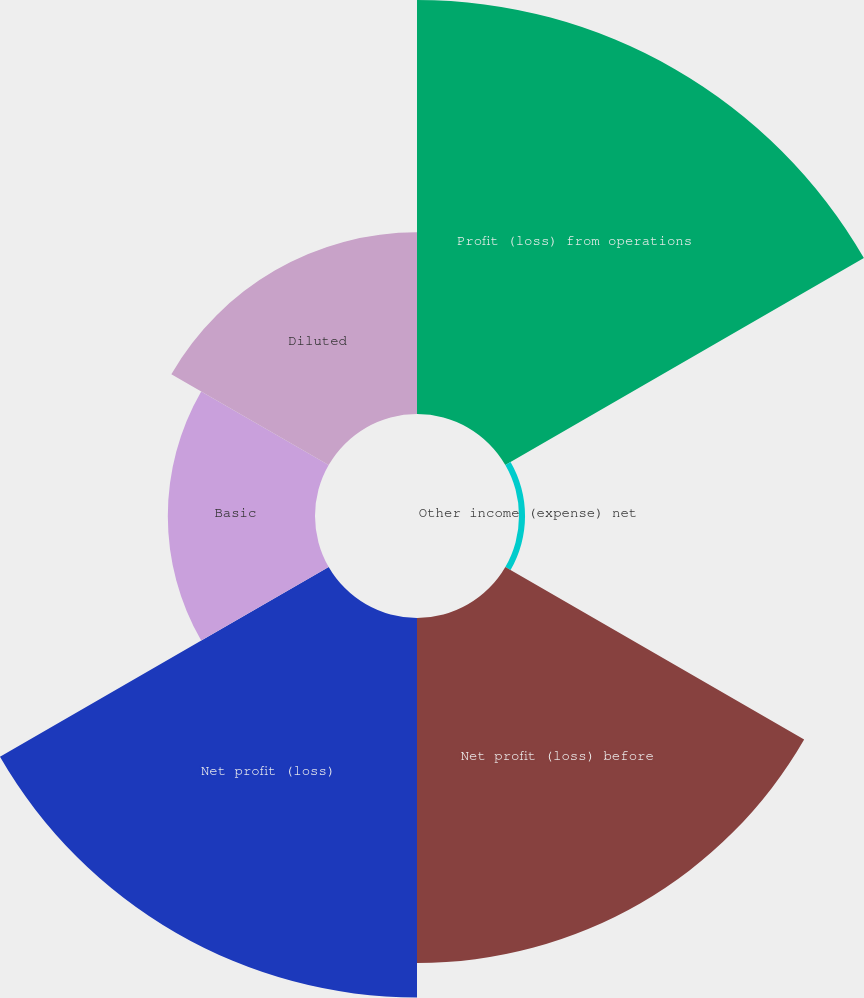Convert chart to OTSL. <chart><loc_0><loc_0><loc_500><loc_500><pie_chart><fcel>Profit (loss) from operations<fcel>Other income (expense) net<fcel>Net profit (loss) before<fcel>Net profit (loss)<fcel>Basic<fcel>Diluted<nl><fcel>28.1%<fcel>0.41%<fcel>23.42%<fcel>25.76%<fcel>9.99%<fcel>12.33%<nl></chart> 